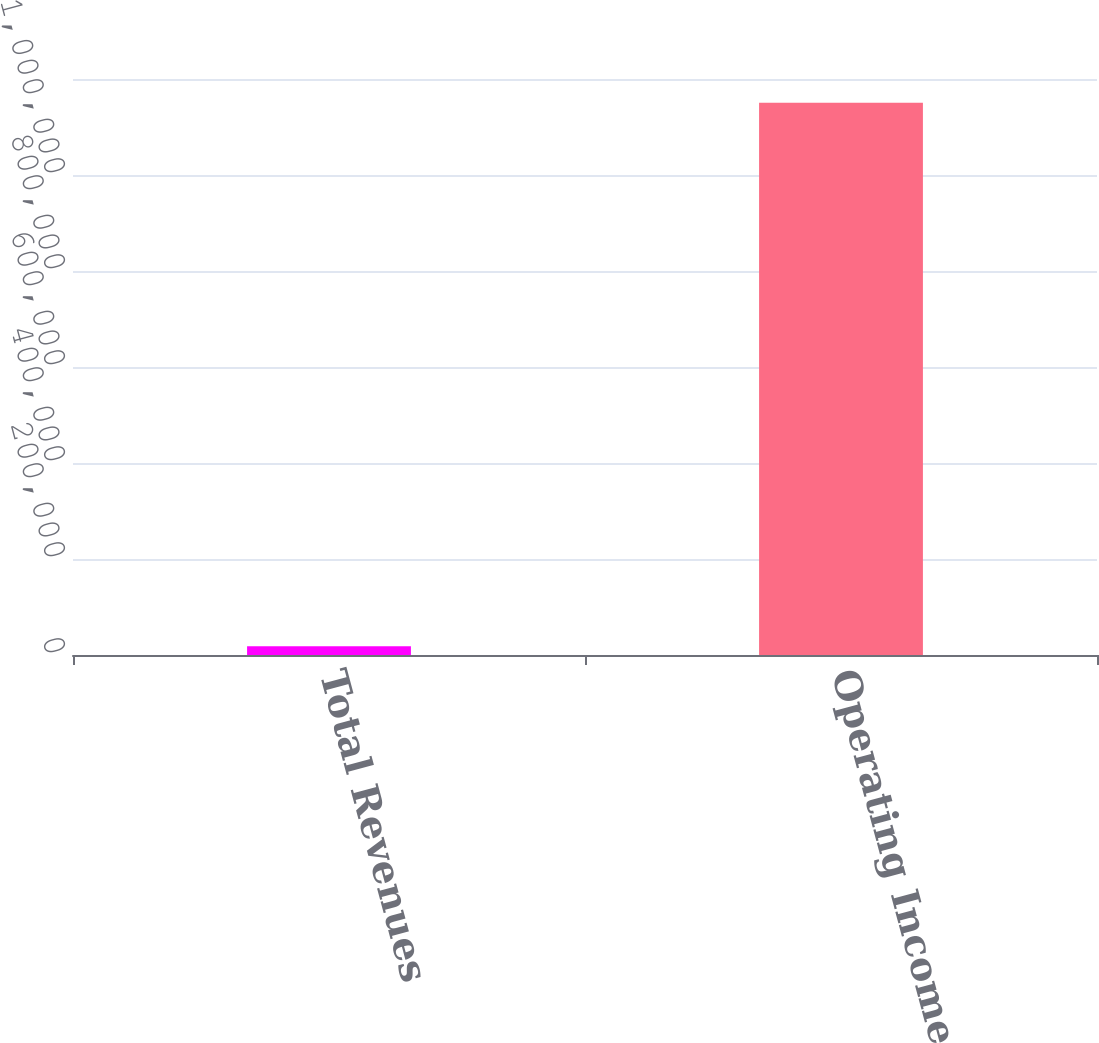Convert chart. <chart><loc_0><loc_0><loc_500><loc_500><bar_chart><fcel>Total Revenues<fcel>Operating Income (Loss)<nl><fcel>18242<fcel>1.15076e+06<nl></chart> 